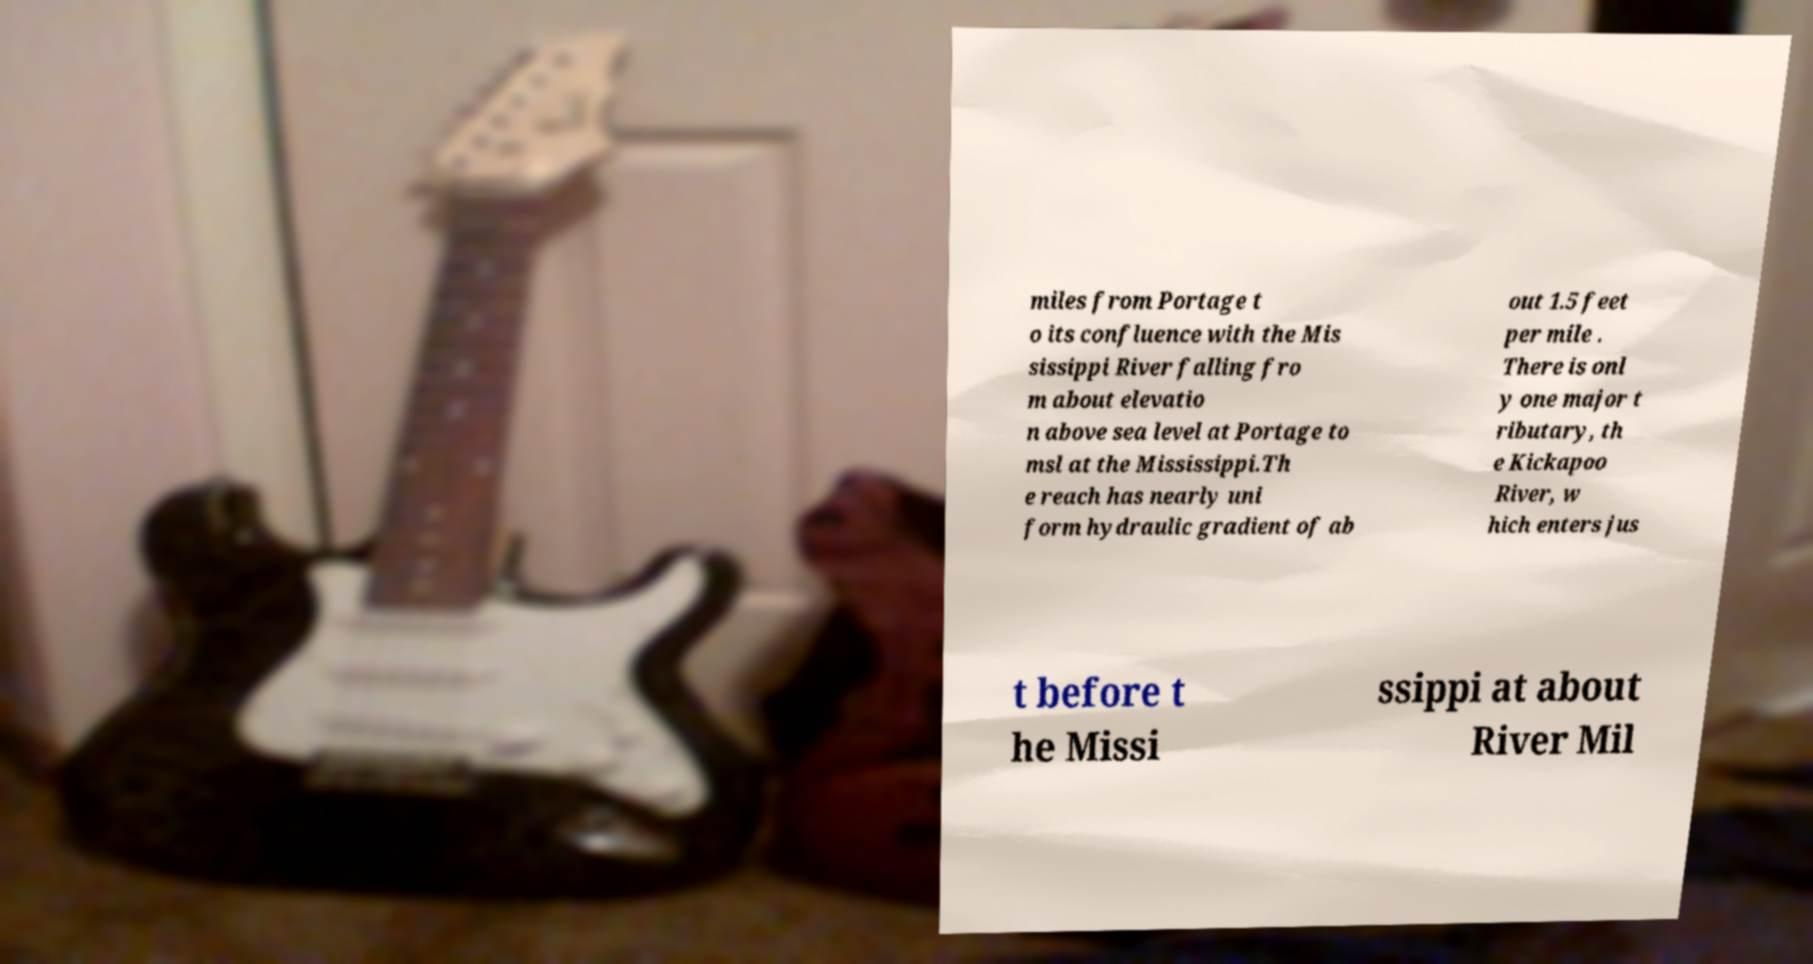Can you accurately transcribe the text from the provided image for me? miles from Portage t o its confluence with the Mis sissippi River falling fro m about elevatio n above sea level at Portage to msl at the Mississippi.Th e reach has nearly uni form hydraulic gradient of ab out 1.5 feet per mile . There is onl y one major t ributary, th e Kickapoo River, w hich enters jus t before t he Missi ssippi at about River Mil 